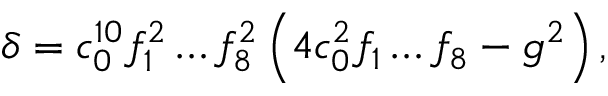<formula> <loc_0><loc_0><loc_500><loc_500>\delta = c _ { 0 } ^ { 1 0 } f _ { 1 } ^ { 2 } \dots f _ { 8 } ^ { 2 } \left ( 4 c _ { 0 } ^ { 2 } f _ { 1 } \dots f _ { 8 } - g ^ { 2 } \right ) ,</formula> 